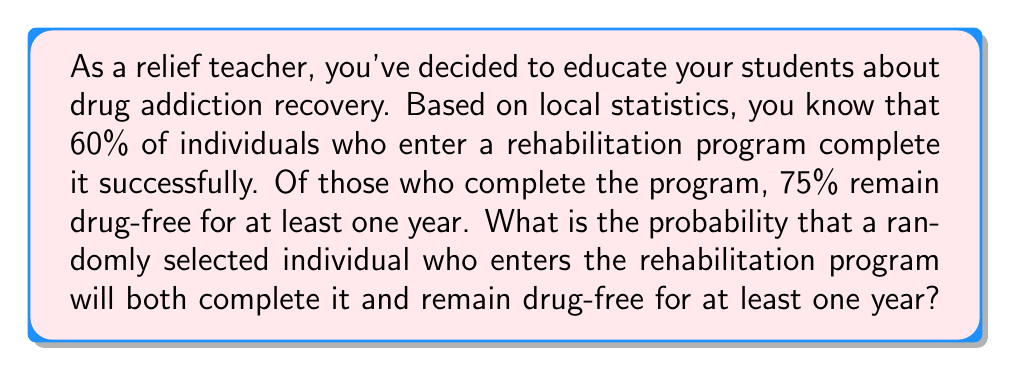Could you help me with this problem? To solve this problem, we need to use the concept of conditional probability. Let's break it down step-by-step:

1. Define the events:
   A: The individual completes the rehabilitation program
   B: The individual remains drug-free for at least one year

2. Given probabilities:
   P(A) = 0.60 (60% complete the program)
   P(B|A) = 0.75 (75% of those who complete the program remain drug-free for a year)

3. We want to find P(A and B), which is the probability of both completing the program and remaining drug-free for a year.

4. Using the multiplication rule of probability:
   P(A and B) = P(A) × P(B|A)

5. Substituting the values:
   P(A and B) = 0.60 × 0.75

6. Calculating the result:
   P(A and B) = 0.45

Therefore, the probability that a randomly selected individual who enters the rehabilitation program will both complete it and remain drug-free for at least one year is 0.45 or 45%.
Answer: The probability is 0.45 or 45%. 